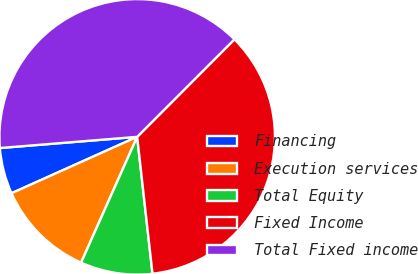Convert chart to OTSL. <chart><loc_0><loc_0><loc_500><loc_500><pie_chart><fcel>Financing<fcel>Execution services<fcel>Total Equity<fcel>Fixed Income<fcel>Total Fixed income<nl><fcel>5.42%<fcel>11.61%<fcel>8.45%<fcel>35.74%<fcel>38.77%<nl></chart> 